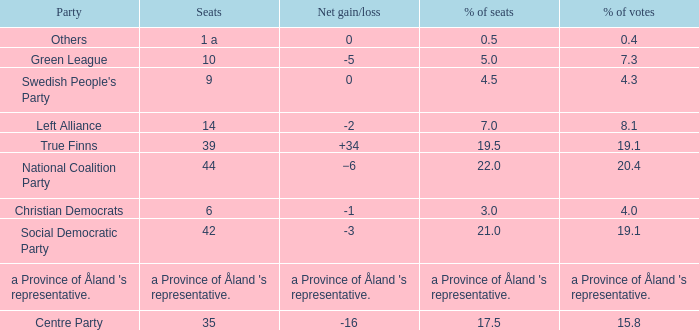When there was a net gain/loss of +34, what was the percentage of seats that party held? 19.5. 